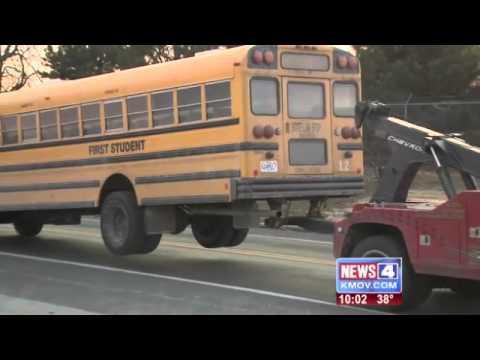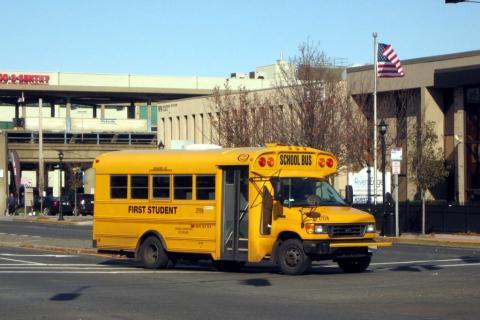The first image is the image on the left, the second image is the image on the right. Examine the images to the left and right. Is the description "In at least one image, a fire is blazing at the front of a bus parked with its red stop sign facing the camera." accurate? Answer yes or no. No. The first image is the image on the left, the second image is the image on the right. Analyze the images presented: Is the assertion "At least one of the schoolbusses is on fire." valid? Answer yes or no. No. 